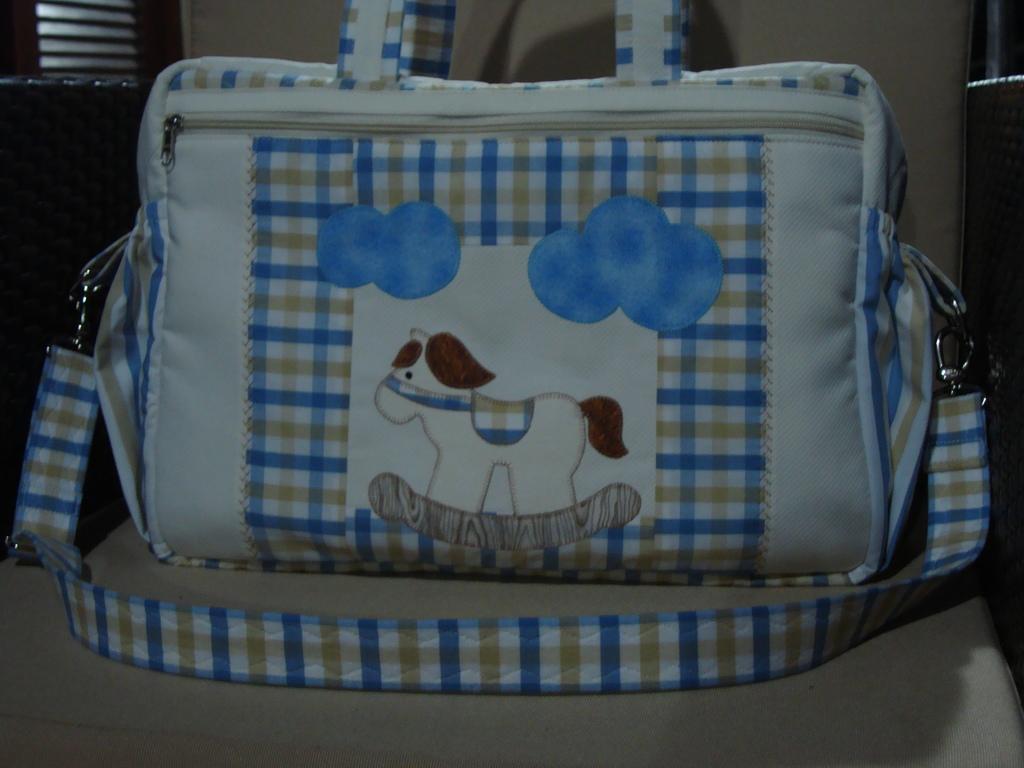Could you give a brief overview of what you see in this image? There is a bag with dog shape art on it on a sofa. 